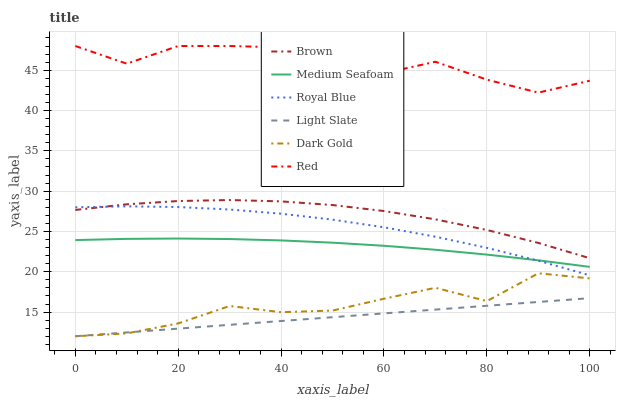Does Light Slate have the minimum area under the curve?
Answer yes or no. Yes. Does Red have the maximum area under the curve?
Answer yes or no. Yes. Does Dark Gold have the minimum area under the curve?
Answer yes or no. No. Does Dark Gold have the maximum area under the curve?
Answer yes or no. No. Is Light Slate the smoothest?
Answer yes or no. Yes. Is Dark Gold the roughest?
Answer yes or no. Yes. Is Dark Gold the smoothest?
Answer yes or no. No. Is Light Slate the roughest?
Answer yes or no. No. Does Dark Gold have the lowest value?
Answer yes or no. Yes. Does Royal Blue have the lowest value?
Answer yes or no. No. Does Red have the highest value?
Answer yes or no. Yes. Does Dark Gold have the highest value?
Answer yes or no. No. Is Light Slate less than Brown?
Answer yes or no. Yes. Is Medium Seafoam greater than Light Slate?
Answer yes or no. Yes. Does Medium Seafoam intersect Royal Blue?
Answer yes or no. Yes. Is Medium Seafoam less than Royal Blue?
Answer yes or no. No. Is Medium Seafoam greater than Royal Blue?
Answer yes or no. No. Does Light Slate intersect Brown?
Answer yes or no. No. 